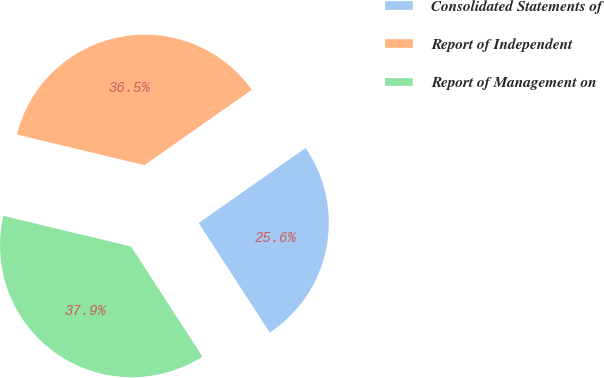Convert chart to OTSL. <chart><loc_0><loc_0><loc_500><loc_500><pie_chart><fcel>Consolidated Statements of<fcel>Report of Independent<fcel>Report of Management on<nl><fcel>25.58%<fcel>36.51%<fcel>37.91%<nl></chart> 